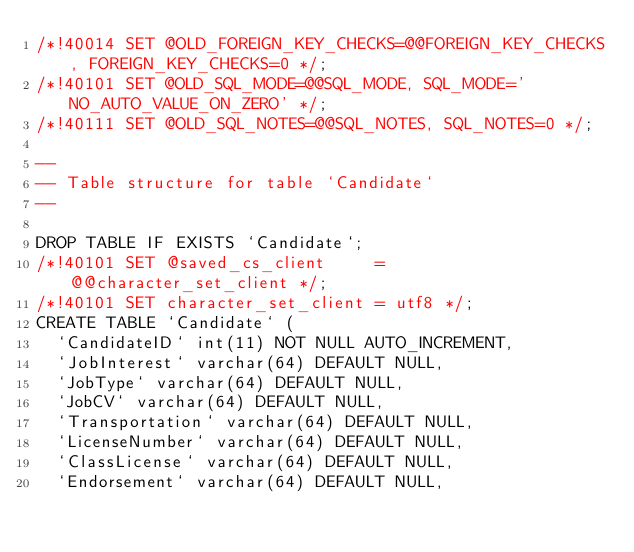Convert code to text. <code><loc_0><loc_0><loc_500><loc_500><_SQL_>/*!40014 SET @OLD_FOREIGN_KEY_CHECKS=@@FOREIGN_KEY_CHECKS, FOREIGN_KEY_CHECKS=0 */;
/*!40101 SET @OLD_SQL_MODE=@@SQL_MODE, SQL_MODE='NO_AUTO_VALUE_ON_ZERO' */;
/*!40111 SET @OLD_SQL_NOTES=@@SQL_NOTES, SQL_NOTES=0 */;

--
-- Table structure for table `Candidate`
--

DROP TABLE IF EXISTS `Candidate`;
/*!40101 SET @saved_cs_client     = @@character_set_client */;
/*!40101 SET character_set_client = utf8 */;
CREATE TABLE `Candidate` (
  `CandidateID` int(11) NOT NULL AUTO_INCREMENT,
  `JobInterest` varchar(64) DEFAULT NULL,
  `JobType` varchar(64) DEFAULT NULL,
  `JobCV` varchar(64) DEFAULT NULL,
  `Transportation` varchar(64) DEFAULT NULL,
  `LicenseNumber` varchar(64) DEFAULT NULL,
  `ClassLicense` varchar(64) DEFAULT NULL,
  `Endorsement` varchar(64) DEFAULT NULL,</code> 